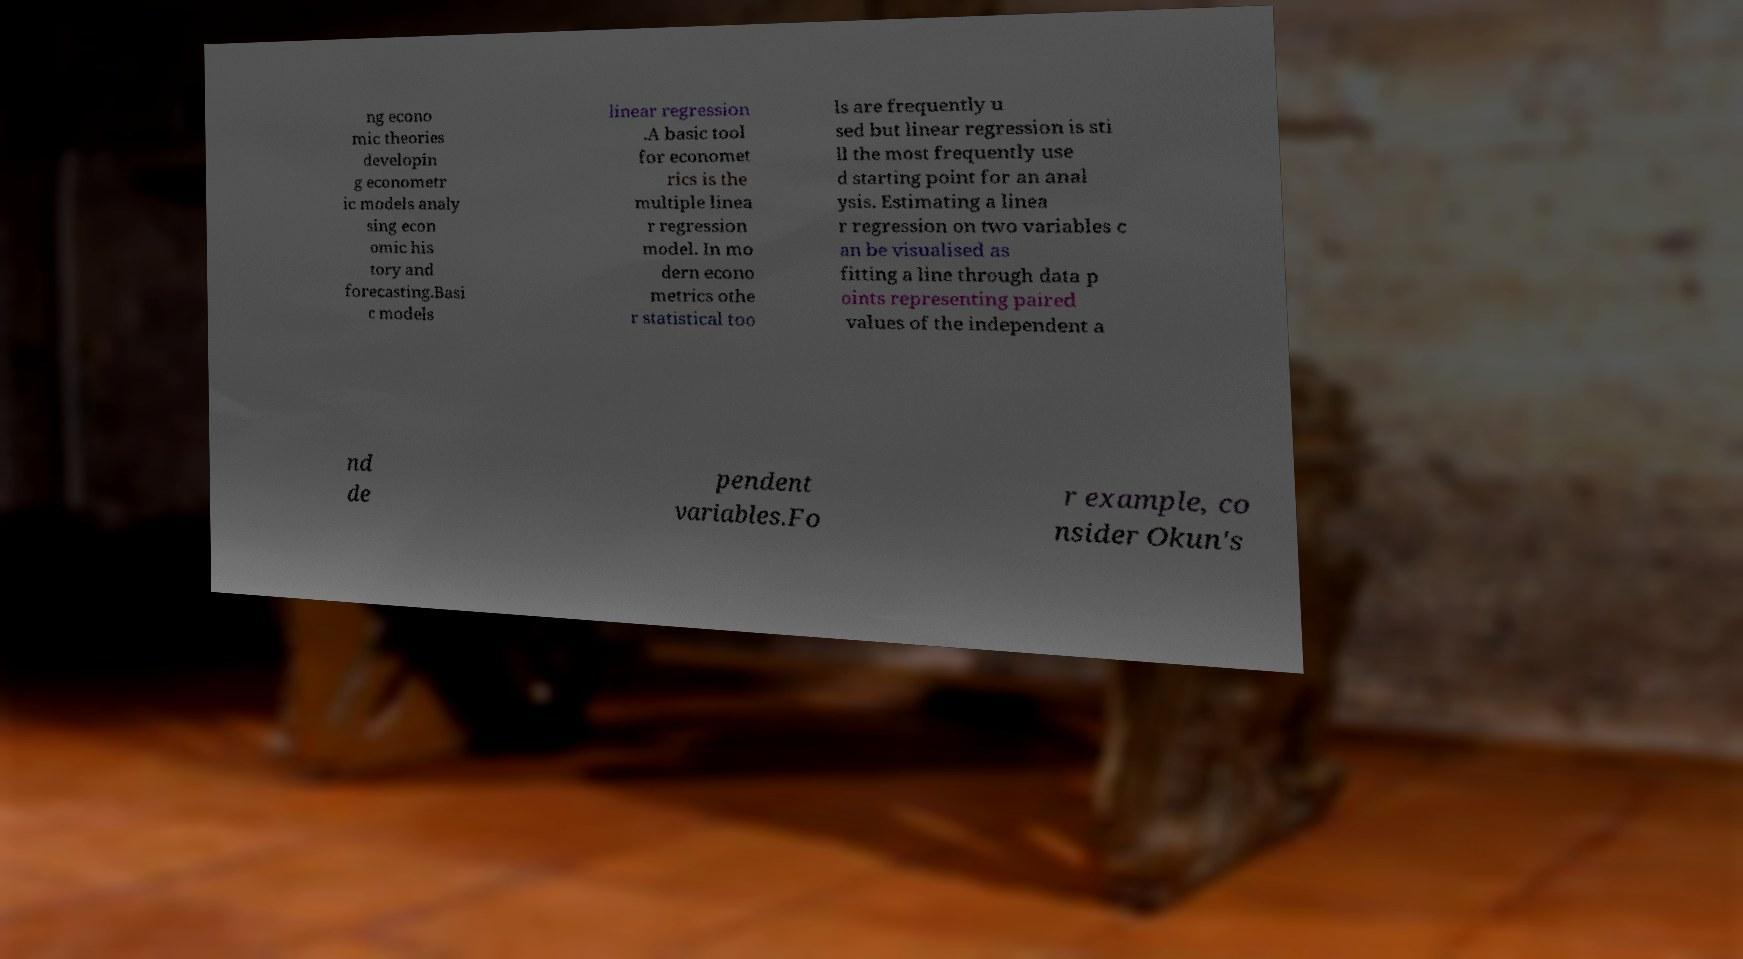There's text embedded in this image that I need extracted. Can you transcribe it verbatim? ng econo mic theories developin g econometr ic models analy sing econ omic his tory and forecasting.Basi c models linear regression .A basic tool for economet rics is the multiple linea r regression model. In mo dern econo metrics othe r statistical too ls are frequently u sed but linear regression is sti ll the most frequently use d starting point for an anal ysis. Estimating a linea r regression on two variables c an be visualised as fitting a line through data p oints representing paired values of the independent a nd de pendent variables.Fo r example, co nsider Okun's 